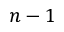Convert formula to latex. <formula><loc_0><loc_0><loc_500><loc_500>n - 1</formula> 